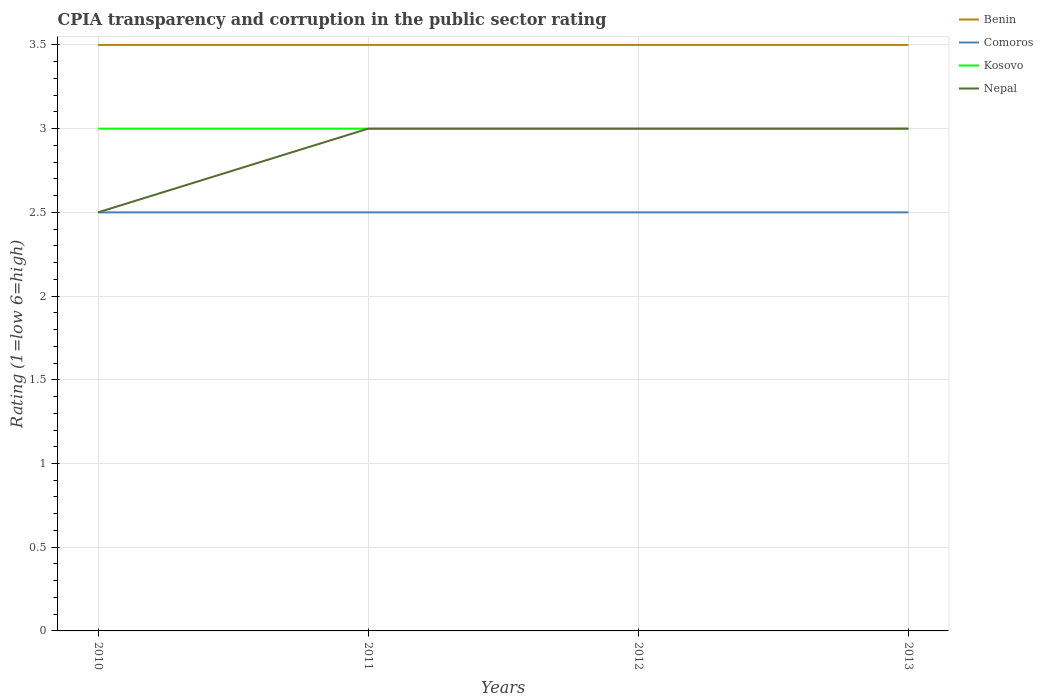How many different coloured lines are there?
Your answer should be very brief. 4. In which year was the CPIA rating in Nepal maximum?
Your answer should be compact. 2010. What is the total CPIA rating in Benin in the graph?
Make the answer very short. 0. What is the difference between the highest and the lowest CPIA rating in Kosovo?
Your answer should be compact. 0. How many lines are there?
Provide a succinct answer. 4. How many years are there in the graph?
Make the answer very short. 4. Does the graph contain grids?
Keep it short and to the point. Yes. How are the legend labels stacked?
Provide a short and direct response. Vertical. What is the title of the graph?
Provide a short and direct response. CPIA transparency and corruption in the public sector rating. What is the label or title of the Y-axis?
Your response must be concise. Rating (1=low 6=high). What is the Rating (1=low 6=high) of Benin in 2010?
Provide a short and direct response. 3.5. What is the Rating (1=low 6=high) in Kosovo in 2010?
Your answer should be compact. 3. What is the Rating (1=low 6=high) of Comoros in 2013?
Offer a very short reply. 2.5. What is the Rating (1=low 6=high) in Kosovo in 2013?
Give a very brief answer. 3. Across all years, what is the maximum Rating (1=low 6=high) in Benin?
Provide a short and direct response. 3.5. Across all years, what is the maximum Rating (1=low 6=high) in Kosovo?
Your answer should be compact. 3. Across all years, what is the minimum Rating (1=low 6=high) in Benin?
Your answer should be compact. 3.5. Across all years, what is the minimum Rating (1=low 6=high) in Comoros?
Offer a terse response. 2.5. Across all years, what is the minimum Rating (1=low 6=high) in Nepal?
Offer a very short reply. 2.5. What is the total Rating (1=low 6=high) in Comoros in the graph?
Your answer should be compact. 10. What is the total Rating (1=low 6=high) of Nepal in the graph?
Make the answer very short. 11.5. What is the difference between the Rating (1=low 6=high) of Comoros in 2010 and that in 2011?
Your answer should be compact. 0. What is the difference between the Rating (1=low 6=high) in Kosovo in 2010 and that in 2011?
Your answer should be very brief. 0. What is the difference between the Rating (1=low 6=high) in Benin in 2010 and that in 2012?
Your response must be concise. 0. What is the difference between the Rating (1=low 6=high) of Comoros in 2010 and that in 2012?
Provide a short and direct response. 0. What is the difference between the Rating (1=low 6=high) of Kosovo in 2010 and that in 2012?
Provide a short and direct response. 0. What is the difference between the Rating (1=low 6=high) of Nepal in 2010 and that in 2013?
Your answer should be very brief. -0.5. What is the difference between the Rating (1=low 6=high) in Benin in 2011 and that in 2012?
Your answer should be very brief. 0. What is the difference between the Rating (1=low 6=high) in Kosovo in 2011 and that in 2012?
Ensure brevity in your answer.  0. What is the difference between the Rating (1=low 6=high) of Comoros in 2011 and that in 2013?
Your answer should be very brief. 0. What is the difference between the Rating (1=low 6=high) in Kosovo in 2011 and that in 2013?
Your answer should be very brief. 0. What is the difference between the Rating (1=low 6=high) in Benin in 2012 and that in 2013?
Give a very brief answer. 0. What is the difference between the Rating (1=low 6=high) in Nepal in 2012 and that in 2013?
Make the answer very short. 0. What is the difference between the Rating (1=low 6=high) in Benin in 2010 and the Rating (1=low 6=high) in Comoros in 2011?
Provide a short and direct response. 1. What is the difference between the Rating (1=low 6=high) in Kosovo in 2010 and the Rating (1=low 6=high) in Nepal in 2011?
Provide a short and direct response. 0. What is the difference between the Rating (1=low 6=high) in Comoros in 2010 and the Rating (1=low 6=high) in Kosovo in 2012?
Make the answer very short. -0.5. What is the difference between the Rating (1=low 6=high) in Kosovo in 2010 and the Rating (1=low 6=high) in Nepal in 2012?
Ensure brevity in your answer.  0. What is the difference between the Rating (1=low 6=high) of Benin in 2010 and the Rating (1=low 6=high) of Nepal in 2013?
Offer a terse response. 0.5. What is the difference between the Rating (1=low 6=high) of Comoros in 2010 and the Rating (1=low 6=high) of Kosovo in 2013?
Give a very brief answer. -0.5. What is the difference between the Rating (1=low 6=high) of Benin in 2011 and the Rating (1=low 6=high) of Kosovo in 2012?
Give a very brief answer. 0.5. What is the difference between the Rating (1=low 6=high) in Comoros in 2011 and the Rating (1=low 6=high) in Kosovo in 2012?
Offer a very short reply. -0.5. What is the difference between the Rating (1=low 6=high) of Comoros in 2011 and the Rating (1=low 6=high) of Nepal in 2012?
Offer a very short reply. -0.5. What is the difference between the Rating (1=low 6=high) in Kosovo in 2011 and the Rating (1=low 6=high) in Nepal in 2012?
Make the answer very short. 0. What is the difference between the Rating (1=low 6=high) of Benin in 2011 and the Rating (1=low 6=high) of Comoros in 2013?
Offer a very short reply. 1. What is the difference between the Rating (1=low 6=high) of Benin in 2011 and the Rating (1=low 6=high) of Kosovo in 2013?
Your response must be concise. 0.5. What is the difference between the Rating (1=low 6=high) in Benin in 2011 and the Rating (1=low 6=high) in Nepal in 2013?
Your answer should be very brief. 0.5. What is the difference between the Rating (1=low 6=high) of Benin in 2012 and the Rating (1=low 6=high) of Kosovo in 2013?
Your answer should be compact. 0.5. What is the difference between the Rating (1=low 6=high) in Benin in 2012 and the Rating (1=low 6=high) in Nepal in 2013?
Ensure brevity in your answer.  0.5. What is the difference between the Rating (1=low 6=high) in Comoros in 2012 and the Rating (1=low 6=high) in Kosovo in 2013?
Provide a succinct answer. -0.5. What is the difference between the Rating (1=low 6=high) in Comoros in 2012 and the Rating (1=low 6=high) in Nepal in 2013?
Provide a succinct answer. -0.5. What is the difference between the Rating (1=low 6=high) in Kosovo in 2012 and the Rating (1=low 6=high) in Nepal in 2013?
Ensure brevity in your answer.  0. What is the average Rating (1=low 6=high) in Benin per year?
Make the answer very short. 3.5. What is the average Rating (1=low 6=high) of Comoros per year?
Offer a very short reply. 2.5. What is the average Rating (1=low 6=high) in Kosovo per year?
Make the answer very short. 3. What is the average Rating (1=low 6=high) of Nepal per year?
Make the answer very short. 2.88. In the year 2010, what is the difference between the Rating (1=low 6=high) of Benin and Rating (1=low 6=high) of Kosovo?
Offer a terse response. 0.5. In the year 2010, what is the difference between the Rating (1=low 6=high) in Benin and Rating (1=low 6=high) in Nepal?
Offer a terse response. 1. In the year 2010, what is the difference between the Rating (1=low 6=high) in Comoros and Rating (1=low 6=high) in Kosovo?
Offer a terse response. -0.5. In the year 2010, what is the difference between the Rating (1=low 6=high) in Comoros and Rating (1=low 6=high) in Nepal?
Provide a succinct answer. 0. In the year 2010, what is the difference between the Rating (1=low 6=high) in Kosovo and Rating (1=low 6=high) in Nepal?
Keep it short and to the point. 0.5. In the year 2011, what is the difference between the Rating (1=low 6=high) of Benin and Rating (1=low 6=high) of Kosovo?
Offer a very short reply. 0.5. In the year 2011, what is the difference between the Rating (1=low 6=high) in Comoros and Rating (1=low 6=high) in Nepal?
Offer a terse response. -0.5. In the year 2012, what is the difference between the Rating (1=low 6=high) in Comoros and Rating (1=low 6=high) in Nepal?
Make the answer very short. -0.5. In the year 2013, what is the difference between the Rating (1=low 6=high) of Benin and Rating (1=low 6=high) of Kosovo?
Provide a short and direct response. 0.5. In the year 2013, what is the difference between the Rating (1=low 6=high) of Benin and Rating (1=low 6=high) of Nepal?
Offer a terse response. 0.5. In the year 2013, what is the difference between the Rating (1=low 6=high) of Kosovo and Rating (1=low 6=high) of Nepal?
Your answer should be very brief. 0. What is the ratio of the Rating (1=low 6=high) of Benin in 2010 to that in 2011?
Keep it short and to the point. 1. What is the ratio of the Rating (1=low 6=high) in Comoros in 2010 to that in 2011?
Your answer should be compact. 1. What is the ratio of the Rating (1=low 6=high) of Kosovo in 2010 to that in 2011?
Give a very brief answer. 1. What is the ratio of the Rating (1=low 6=high) of Kosovo in 2010 to that in 2012?
Offer a very short reply. 1. What is the ratio of the Rating (1=low 6=high) in Comoros in 2010 to that in 2013?
Ensure brevity in your answer.  1. What is the ratio of the Rating (1=low 6=high) in Kosovo in 2010 to that in 2013?
Ensure brevity in your answer.  1. What is the ratio of the Rating (1=low 6=high) of Benin in 2011 to that in 2012?
Your answer should be very brief. 1. What is the ratio of the Rating (1=low 6=high) in Comoros in 2011 to that in 2012?
Make the answer very short. 1. What is the ratio of the Rating (1=low 6=high) in Kosovo in 2011 to that in 2013?
Your response must be concise. 1. What is the ratio of the Rating (1=low 6=high) in Nepal in 2011 to that in 2013?
Provide a short and direct response. 1. What is the ratio of the Rating (1=low 6=high) in Comoros in 2012 to that in 2013?
Keep it short and to the point. 1. What is the ratio of the Rating (1=low 6=high) of Nepal in 2012 to that in 2013?
Ensure brevity in your answer.  1. What is the difference between the highest and the second highest Rating (1=low 6=high) in Benin?
Provide a short and direct response. 0. What is the difference between the highest and the second highest Rating (1=low 6=high) of Comoros?
Your answer should be very brief. 0. What is the difference between the highest and the lowest Rating (1=low 6=high) of Benin?
Offer a very short reply. 0. What is the difference between the highest and the lowest Rating (1=low 6=high) in Comoros?
Your answer should be compact. 0. 